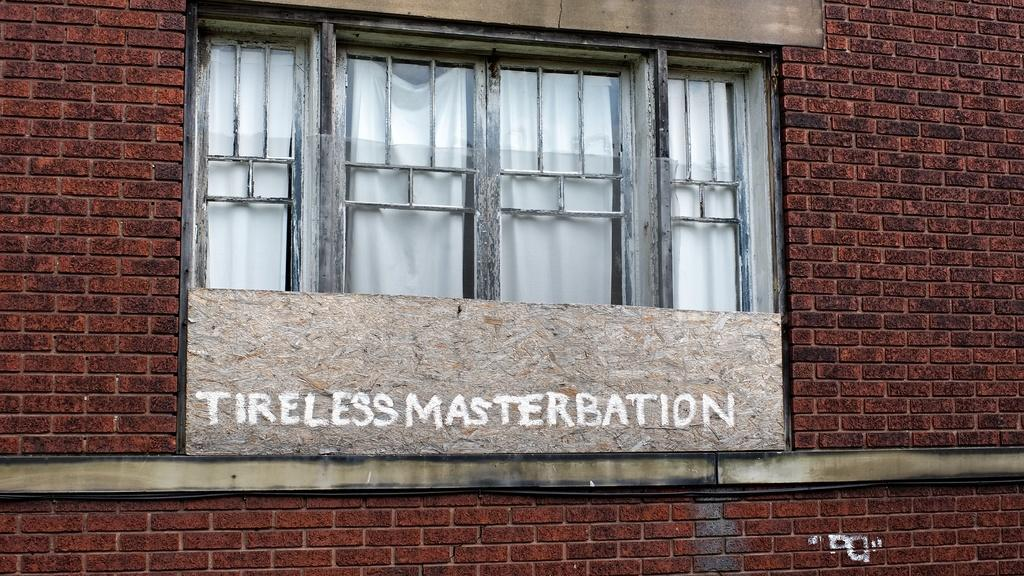What type of material is used for the walls in the image? There are brick walls in the image. What type of windows are present in the image? There are glass windows in the image. What object can be seen in the image with text on it? There is a board in the image with text on it. What can be seen through the glass windows? There are curtains visible through the glass windows. What type of bun is being used to hold the curtains in place in the image? There is no bun present in the image; the curtains are held in place by other means, such as curtain rods or hooks. What color is the copper used for the board in the image? There is no copper used for the board in the image; the board is made of a different material, and its color is not mentioned in the provided facts. 